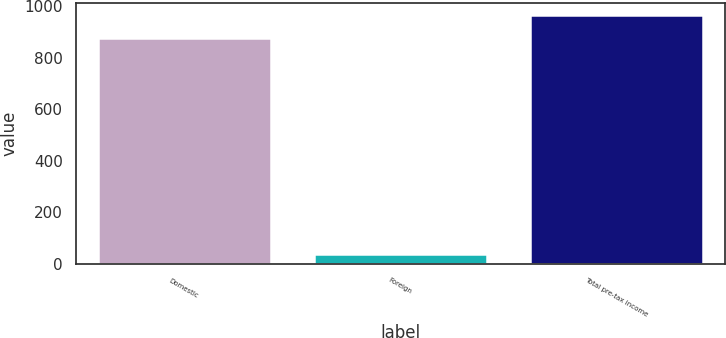Convert chart to OTSL. <chart><loc_0><loc_0><loc_500><loc_500><bar_chart><fcel>Domestic<fcel>Foreign<fcel>Total pre-tax income<nl><fcel>876.1<fcel>39.5<fcel>963.71<nl></chart> 